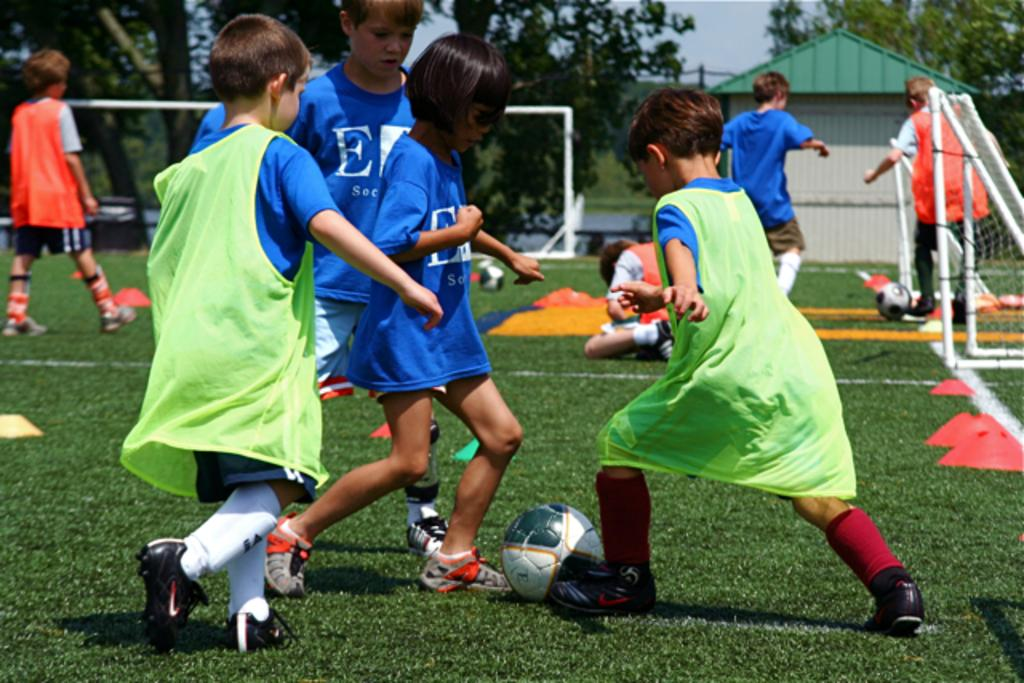What is the main subject of the image? The main subject of the image is a group of kids. What are the kids doing in the image? The kids are playing football. What type of leather material can be seen in the image? There is no leather material present in the image. What kind of jelly dessert is being served to the kids in the image? There is no jelly dessert present in the image; the kids are playing football. How many beds are visible in the image? There are no beds visible in the image; it features a group of kids playing football. 